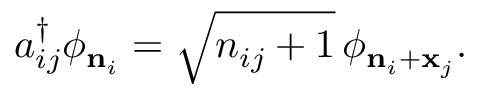Convert formula to latex. <formula><loc_0><loc_0><loc_500><loc_500>a _ { i j } ^ { \dag } \phi _ { { n } _ { i } } = \sqrt { n _ { i j } + 1 } \, \phi _ { { n } _ { i } + { x } _ { j } } .</formula> 